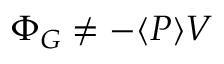Convert formula to latex. <formula><loc_0><loc_0><loc_500><loc_500>\Phi _ { G } \neq - \langle P \rangle V</formula> 